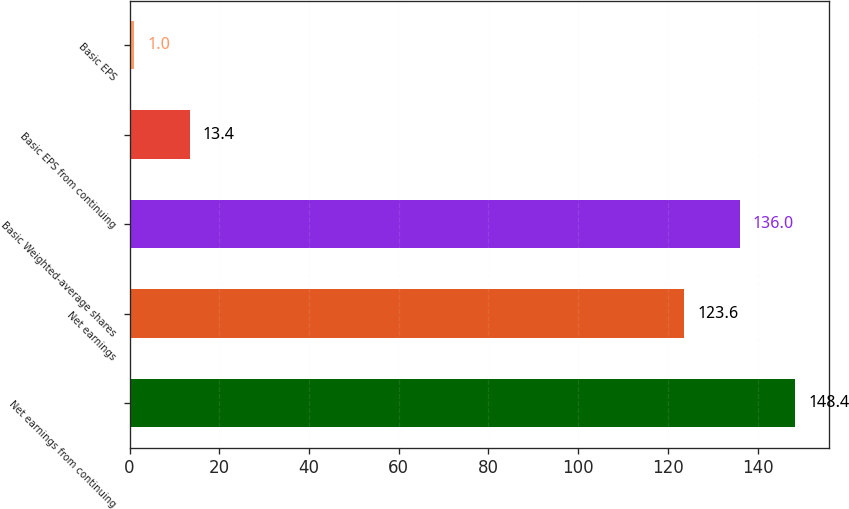Convert chart to OTSL. <chart><loc_0><loc_0><loc_500><loc_500><bar_chart><fcel>Net earnings from continuing<fcel>Net earnings<fcel>Basic Weighted-average shares<fcel>Basic EPS from continuing<fcel>Basic EPS<nl><fcel>148.4<fcel>123.6<fcel>136<fcel>13.4<fcel>1<nl></chart> 